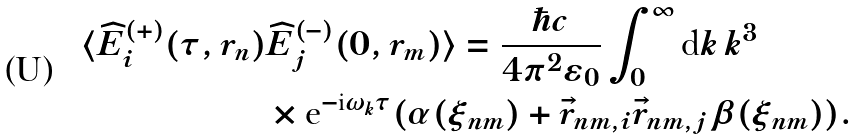<formula> <loc_0><loc_0><loc_500><loc_500>\langle \widehat { E } _ { i } ^ { ( + ) } ( \tau , r _ { n } ) & \widehat { E } _ { j } ^ { ( - ) } ( 0 , r _ { m } ) \rangle = \frac { \hbar { c } } { 4 \pi ^ { 2 } \varepsilon _ { 0 } } \int _ { 0 } ^ { \infty } \text {d} k \, k ^ { 3 } \, \\ & \times \text {e} ^ { - \text {i} \omega _ { k } \tau } ( \alpha ( \xi _ { n m } ) + \vec { r } _ { n m , i } \vec { r } _ { n m , j } \beta ( \xi _ { n m } ) ) .</formula> 